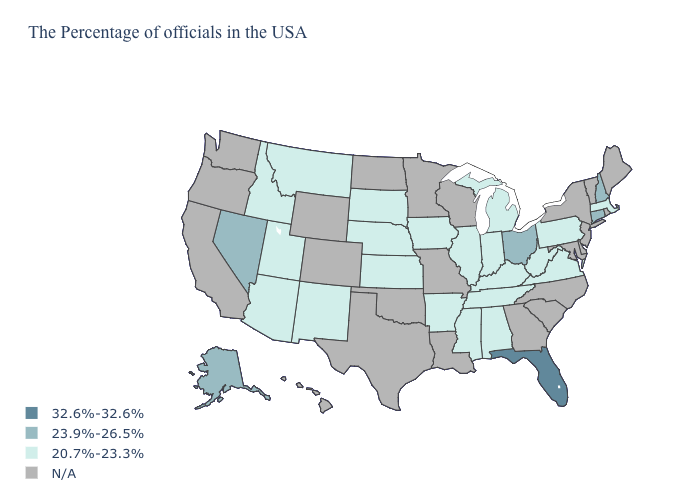Name the states that have a value in the range N/A?
Short answer required. Maine, Rhode Island, Vermont, New York, New Jersey, Delaware, Maryland, North Carolina, South Carolina, Georgia, Wisconsin, Louisiana, Missouri, Minnesota, Oklahoma, Texas, North Dakota, Wyoming, Colorado, California, Washington, Oregon, Hawaii. What is the lowest value in the USA?
Answer briefly. 20.7%-23.3%. What is the value of New York?
Be succinct. N/A. Does New Hampshire have the highest value in the USA?
Give a very brief answer. No. How many symbols are there in the legend?
Keep it brief. 4. What is the value of Ohio?
Concise answer only. 23.9%-26.5%. Which states have the highest value in the USA?
Write a very short answer. Florida. Does Tennessee have the highest value in the South?
Be succinct. No. Name the states that have a value in the range 23.9%-26.5%?
Be succinct. New Hampshire, Connecticut, Ohio, Nevada, Alaska. Does the map have missing data?
Give a very brief answer. Yes. Which states have the highest value in the USA?
Write a very short answer. Florida. What is the lowest value in the USA?
Give a very brief answer. 20.7%-23.3%. Which states have the lowest value in the MidWest?
Give a very brief answer. Michigan, Indiana, Illinois, Iowa, Kansas, Nebraska, South Dakota. Does the map have missing data?
Keep it brief. Yes. How many symbols are there in the legend?
Give a very brief answer. 4. 